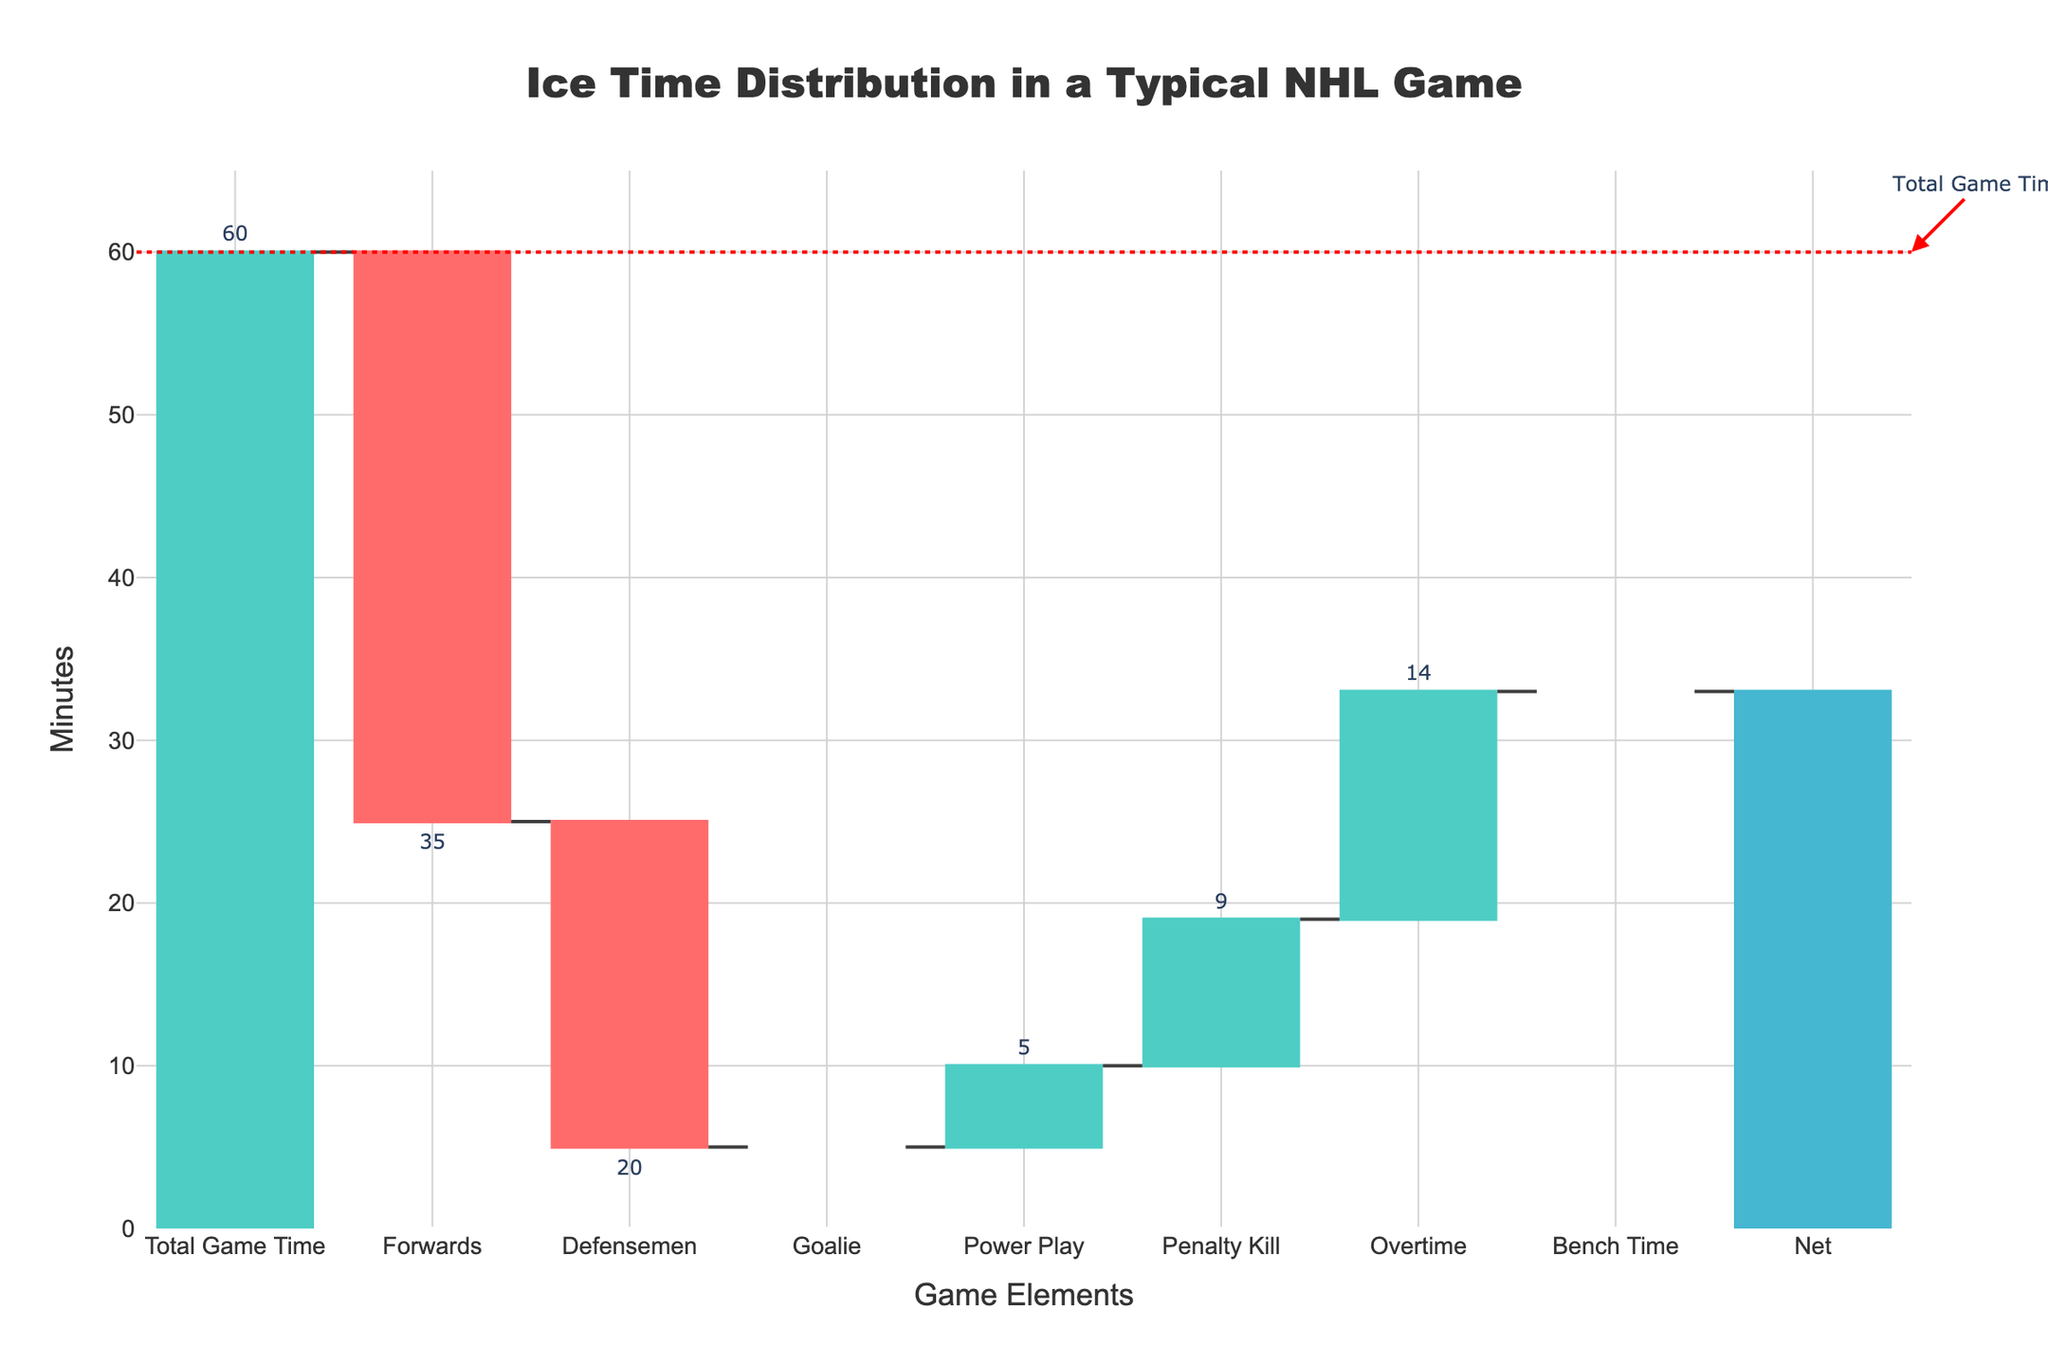What's the title of the chart? The title is displayed at the top center of the figure. It reads "Ice Time Distribution in a Typical NHL Game".
Answer: Ice Time Distribution in a Typical NHL Game How many minutes did Forwards play? The "Forwards" bar is labeled outside with the number of minutes. The indicated number is -35.
Answer: 35 minutes What is the total added time from Power Play and Overtime? Sum the visual indicators of additional time from Power Play and Overtime bars. Power Play is +5 and Overtime is +5, so their total is 5 + 5.
Answer: 10 minutes Which position had the largest decrease in ice time? Compare the lengths and values of the downward bars representing decreases. The "Goalie" bar shows the largest decrease with -60.
Answer: Goalie How much total bench time is there in the game? Refer to the "Bench Time" bar labeled -14. This indicates the total bench time, which is a decrease of 14 minutes.
Answer: 14 minutes How is penalty kill time visually represented in the chart? The bar for "Penalty Kill" is colored differently to indicate additional time and is labeled outside with +4.
Answer: Additional increase of 4 minutes What is the final net calculation for the ice time distribution? To find the Net value, sum up the changes: 60 (Total Game Time) - 35 (Forwards) - 20 (Defensemen) - 60 (Goalie) + 5 (Power Play) + 4 (Penalty Kill) + 5 (Overtime) - 14 (Bench Time). This results in 60 - 35 - 20 - 60 + 5 + 4 + 5 - 14.
Answer: -55 minutes Compare the ice time between Power Play and Penalty Kill. Which one is greater? Check the values of "Power Play" (+5) and "Penalty Kill" (+4). The bar for Power Play is slightly longer, indicating more time.
Answer: Power Play What vertical line indicates the total game time, and how is it annotated? There is a dotted line at the 60-minute mark with an annotation reading "Total Game Time".
Answer: Vertical dotted line at 60 minutes What does the "Net" position stand for in this chart? The "Net" position represents the sum of all the other changes, indicating the overall net calculation of the ice time distribution.
Answer: Overall net calculation 